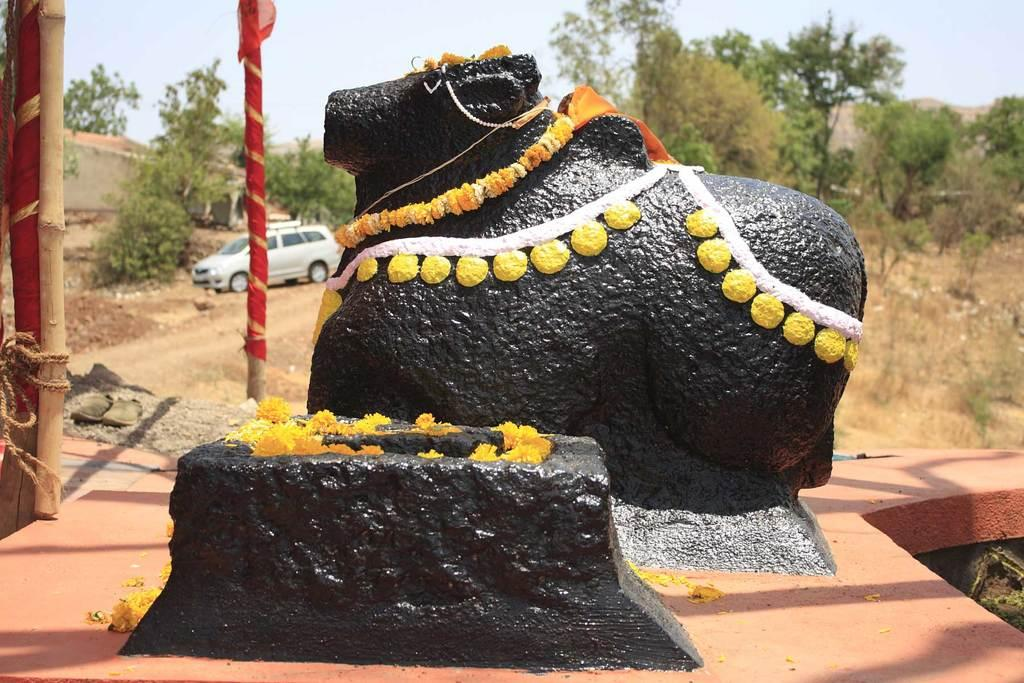What is the main subject of the image? There is an idol in the image. What is adorning the idol? There are garlands on the idol. What can be seen near the idol? There is a stone near the idol. What is visible in the background of the image? Poles, trees, and the sky are visible in the background of the image. What type of vehicle is present in the image? There is a vehicle in the image. What is the aftermath of the fight depicted in the image? There is no fight depicted in the image; it features an idol with garlands and a stone nearby. Can you tell me how many lamps are present in the image? There is no lamp present in the image. 